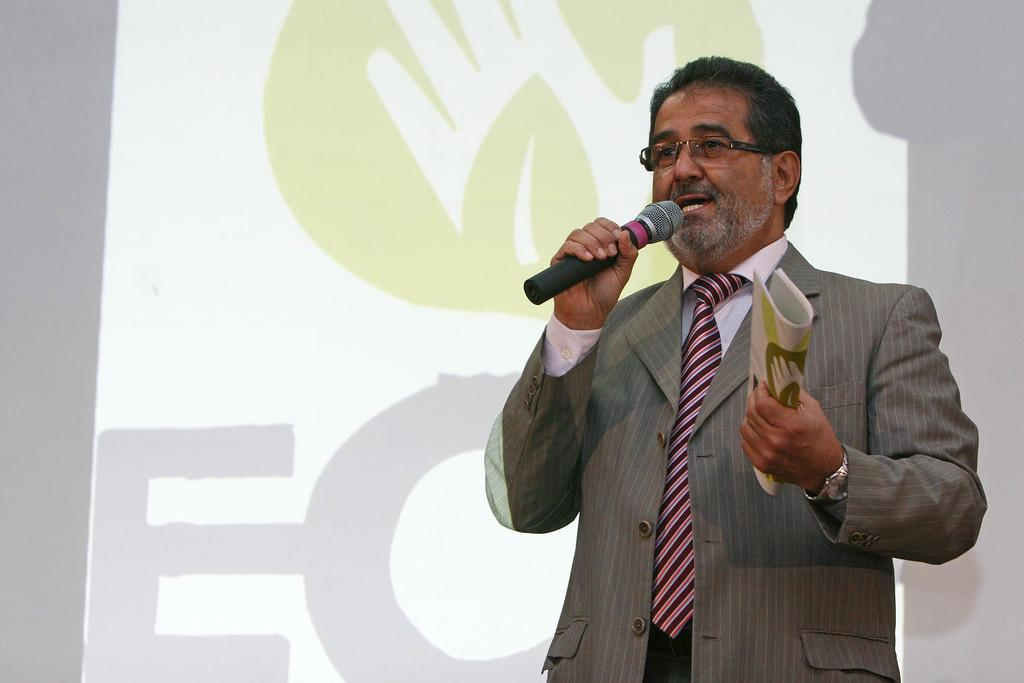Who is present in the image? There is a man in the image. What is the man holding in his hand? The man is holding a microphone in his hand. What other object can be seen in the image? There is a book in the image. What type of doctor is attending to the patient in the image? There is no doctor or patient present in the image; it features a man holding a microphone and a book. What type of notebook is the soldier using during the battle in the image? There is no notebook or battle present in the image. 